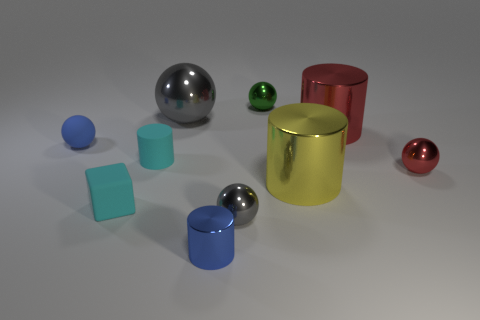Subtract all red balls. How many balls are left? 4 Subtract all tiny blue spheres. How many spheres are left? 4 Subtract all brown spheres. Subtract all brown cylinders. How many spheres are left? 5 Subtract all blocks. How many objects are left? 9 Add 2 cyan matte cylinders. How many cyan matte cylinders exist? 3 Subtract 0 cyan spheres. How many objects are left? 10 Subtract all purple matte things. Subtract all tiny cyan blocks. How many objects are left? 9 Add 4 red balls. How many red balls are left? 5 